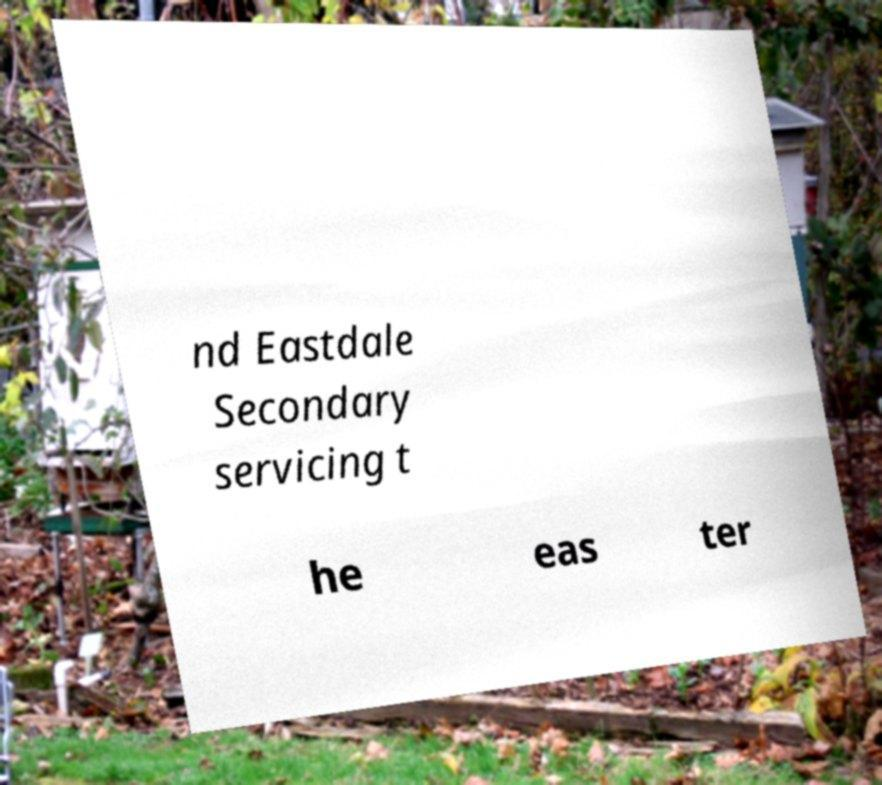Can you read and provide the text displayed in the image?This photo seems to have some interesting text. Can you extract and type it out for me? nd Eastdale Secondary servicing t he eas ter 